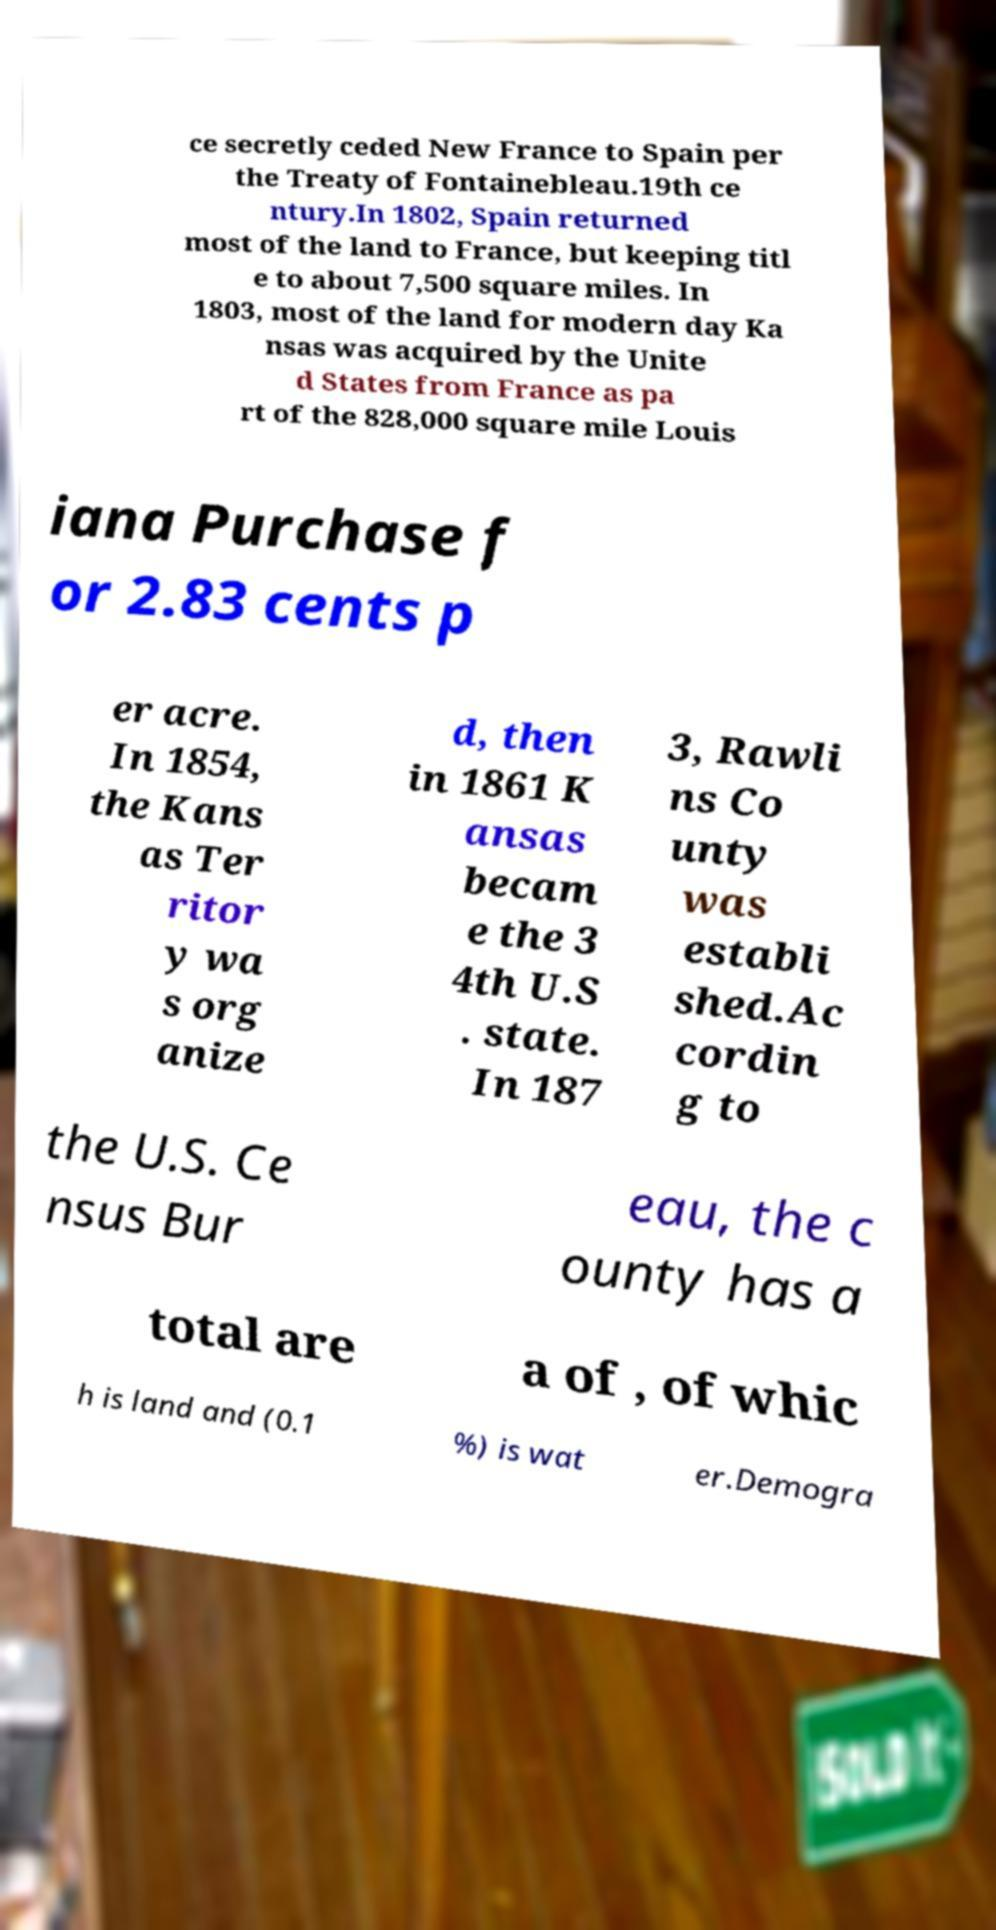Please identify and transcribe the text found in this image. ce secretly ceded New France to Spain per the Treaty of Fontainebleau.19th ce ntury.In 1802, Spain returned most of the land to France, but keeping titl e to about 7,500 square miles. In 1803, most of the land for modern day Ka nsas was acquired by the Unite d States from France as pa rt of the 828,000 square mile Louis iana Purchase f or 2.83 cents p er acre. In 1854, the Kans as Ter ritor y wa s org anize d, then in 1861 K ansas becam e the 3 4th U.S . state. In 187 3, Rawli ns Co unty was establi shed.Ac cordin g to the U.S. Ce nsus Bur eau, the c ounty has a total are a of , of whic h is land and (0.1 %) is wat er.Demogra 